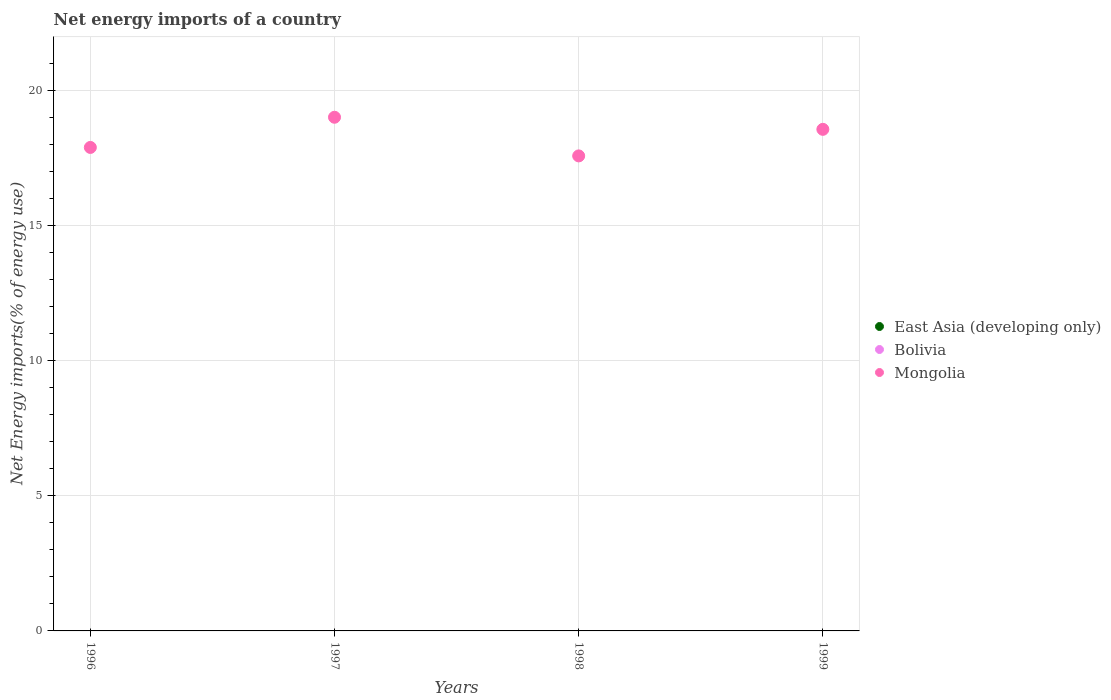How many different coloured dotlines are there?
Your response must be concise. 1. Is the number of dotlines equal to the number of legend labels?
Your response must be concise. No. What is the net energy imports in East Asia (developing only) in 1998?
Give a very brief answer. 0. Across all years, what is the maximum net energy imports in Mongolia?
Your answer should be very brief. 19.01. Across all years, what is the minimum net energy imports in Mongolia?
Your answer should be very brief. 17.58. In which year was the net energy imports in Mongolia maximum?
Your response must be concise. 1997. What is the total net energy imports in Mongolia in the graph?
Offer a very short reply. 73.05. What is the difference between the net energy imports in Mongolia in 1996 and that in 1999?
Provide a short and direct response. -0.67. What is the difference between the net energy imports in Mongolia in 1997 and the net energy imports in East Asia (developing only) in 1999?
Ensure brevity in your answer.  19.01. What is the ratio of the net energy imports in Mongolia in 1997 to that in 1998?
Offer a very short reply. 1.08. What is the difference between the highest and the second highest net energy imports in Mongolia?
Offer a terse response. 0.45. What is the difference between the highest and the lowest net energy imports in Mongolia?
Offer a very short reply. 1.43. In how many years, is the net energy imports in East Asia (developing only) greater than the average net energy imports in East Asia (developing only) taken over all years?
Offer a terse response. 0. Does the net energy imports in Bolivia monotonically increase over the years?
Provide a succinct answer. Yes. Is the net energy imports in Mongolia strictly less than the net energy imports in Bolivia over the years?
Your response must be concise. No. How many dotlines are there?
Make the answer very short. 1. Are the values on the major ticks of Y-axis written in scientific E-notation?
Make the answer very short. No. Does the graph contain grids?
Ensure brevity in your answer.  Yes. Where does the legend appear in the graph?
Your response must be concise. Center right. How are the legend labels stacked?
Your response must be concise. Vertical. What is the title of the graph?
Provide a short and direct response. Net energy imports of a country. Does "Bahrain" appear as one of the legend labels in the graph?
Your answer should be compact. No. What is the label or title of the Y-axis?
Offer a very short reply. Net Energy imports(% of energy use). What is the Net Energy imports(% of energy use) in Mongolia in 1996?
Your answer should be very brief. 17.89. What is the Net Energy imports(% of energy use) in Mongolia in 1997?
Your answer should be compact. 19.01. What is the Net Energy imports(% of energy use) in East Asia (developing only) in 1998?
Provide a succinct answer. 0. What is the Net Energy imports(% of energy use) of Bolivia in 1998?
Your response must be concise. 0. What is the Net Energy imports(% of energy use) of Mongolia in 1998?
Your answer should be very brief. 17.58. What is the Net Energy imports(% of energy use) in East Asia (developing only) in 1999?
Your answer should be compact. 0. What is the Net Energy imports(% of energy use) in Bolivia in 1999?
Offer a terse response. 0. What is the Net Energy imports(% of energy use) in Mongolia in 1999?
Give a very brief answer. 18.56. Across all years, what is the maximum Net Energy imports(% of energy use) in Mongolia?
Your answer should be very brief. 19.01. Across all years, what is the minimum Net Energy imports(% of energy use) of Mongolia?
Provide a short and direct response. 17.58. What is the total Net Energy imports(% of energy use) of Bolivia in the graph?
Your answer should be very brief. 0. What is the total Net Energy imports(% of energy use) in Mongolia in the graph?
Offer a very short reply. 73.05. What is the difference between the Net Energy imports(% of energy use) of Mongolia in 1996 and that in 1997?
Offer a very short reply. -1.12. What is the difference between the Net Energy imports(% of energy use) of Mongolia in 1996 and that in 1998?
Ensure brevity in your answer.  0.31. What is the difference between the Net Energy imports(% of energy use) of Mongolia in 1996 and that in 1999?
Offer a terse response. -0.67. What is the difference between the Net Energy imports(% of energy use) in Mongolia in 1997 and that in 1998?
Offer a very short reply. 1.43. What is the difference between the Net Energy imports(% of energy use) of Mongolia in 1997 and that in 1999?
Provide a succinct answer. 0.45. What is the difference between the Net Energy imports(% of energy use) in Mongolia in 1998 and that in 1999?
Ensure brevity in your answer.  -0.98. What is the average Net Energy imports(% of energy use) in Bolivia per year?
Ensure brevity in your answer.  0. What is the average Net Energy imports(% of energy use) of Mongolia per year?
Keep it short and to the point. 18.26. What is the ratio of the Net Energy imports(% of energy use) of Mongolia in 1996 to that in 1998?
Offer a very short reply. 1.02. What is the ratio of the Net Energy imports(% of energy use) of Mongolia in 1996 to that in 1999?
Offer a terse response. 0.96. What is the ratio of the Net Energy imports(% of energy use) of Mongolia in 1997 to that in 1998?
Offer a very short reply. 1.08. What is the ratio of the Net Energy imports(% of energy use) of Mongolia in 1997 to that in 1999?
Your response must be concise. 1.02. What is the ratio of the Net Energy imports(% of energy use) of Mongolia in 1998 to that in 1999?
Your response must be concise. 0.95. What is the difference between the highest and the second highest Net Energy imports(% of energy use) of Mongolia?
Keep it short and to the point. 0.45. What is the difference between the highest and the lowest Net Energy imports(% of energy use) of Mongolia?
Keep it short and to the point. 1.43. 